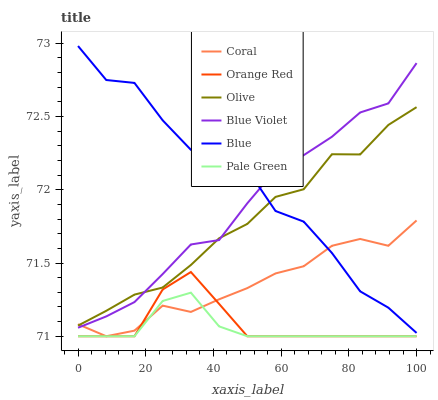Does Coral have the minimum area under the curve?
Answer yes or no. No. Does Coral have the maximum area under the curve?
Answer yes or no. No. Is Coral the smoothest?
Answer yes or no. No. Is Coral the roughest?
Answer yes or no. No. Does Olive have the lowest value?
Answer yes or no. No. Does Coral have the highest value?
Answer yes or no. No. Is Orange Red less than Olive?
Answer yes or no. Yes. Is Blue Violet greater than Pale Green?
Answer yes or no. Yes. Does Orange Red intersect Olive?
Answer yes or no. No. 